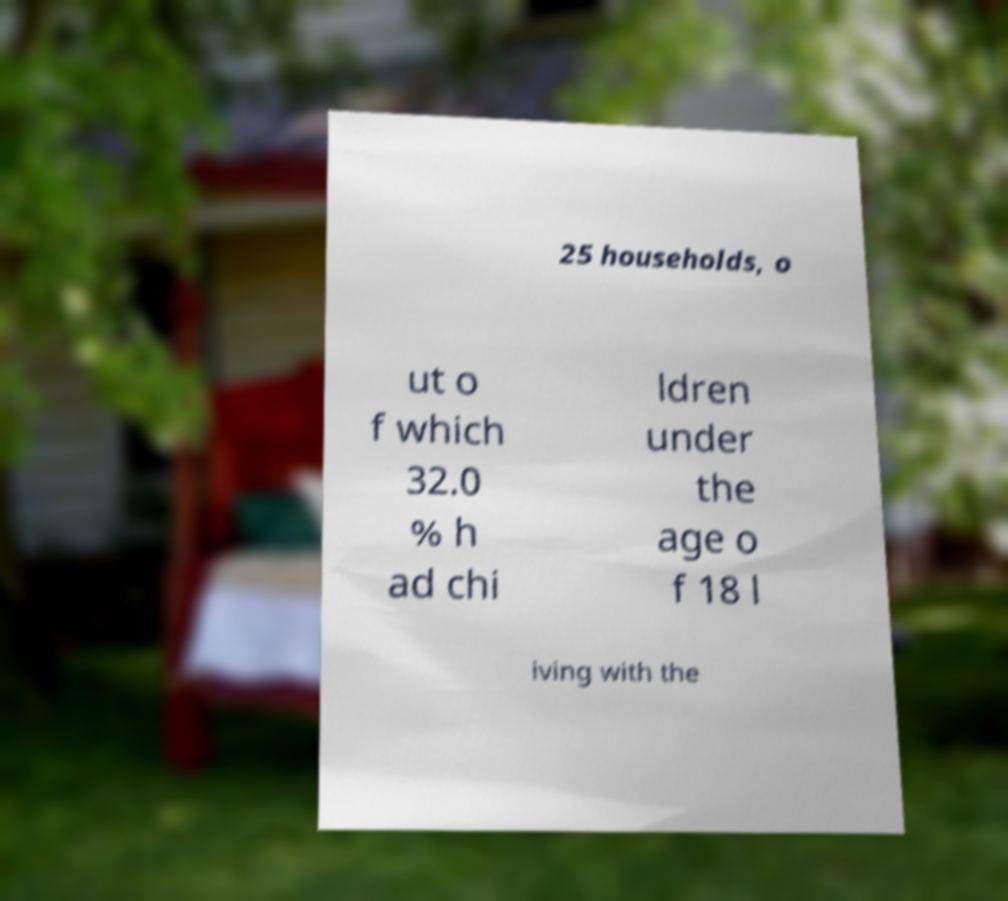What messages or text are displayed in this image? I need them in a readable, typed format. 25 households, o ut o f which 32.0 % h ad chi ldren under the age o f 18 l iving with the 